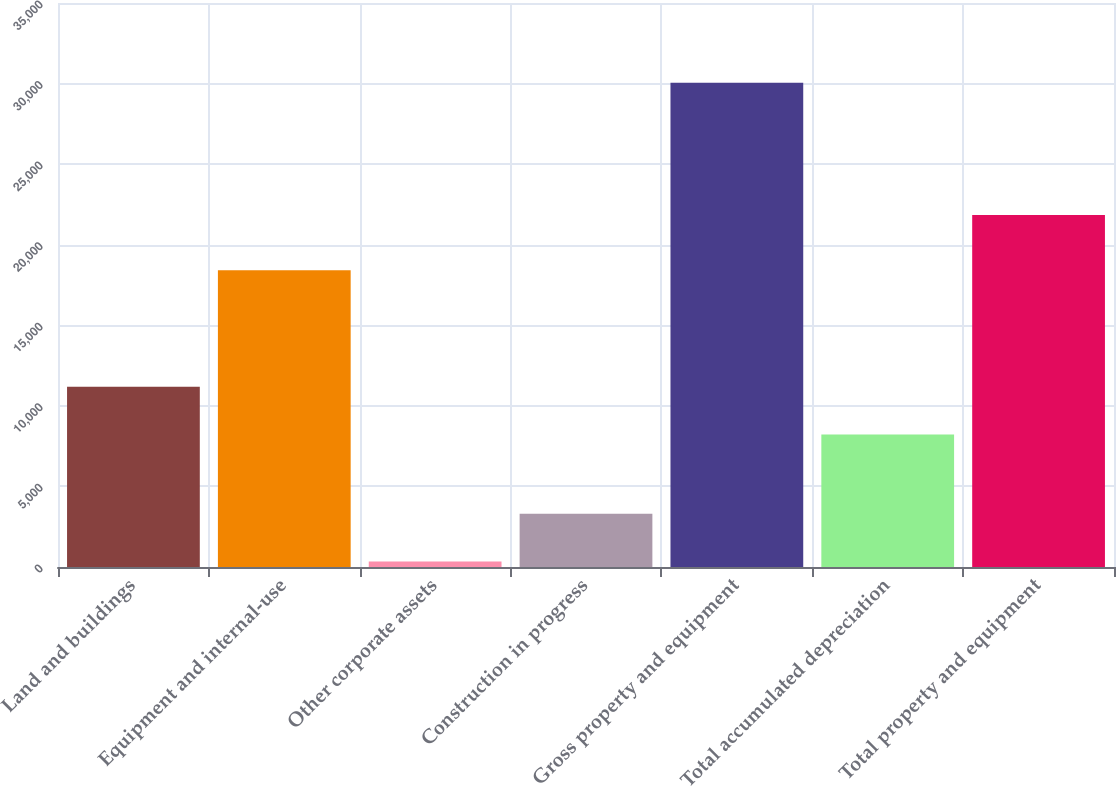<chart> <loc_0><loc_0><loc_500><loc_500><bar_chart><fcel>Land and buildings<fcel>Equipment and internal-use<fcel>Other corporate assets<fcel>Construction in progress<fcel>Gross property and equipment<fcel>Total accumulated depreciation<fcel>Total property and equipment<nl><fcel>11186.9<fcel>18417<fcel>334<fcel>3305.9<fcel>30053<fcel>8215<fcel>21838<nl></chart> 